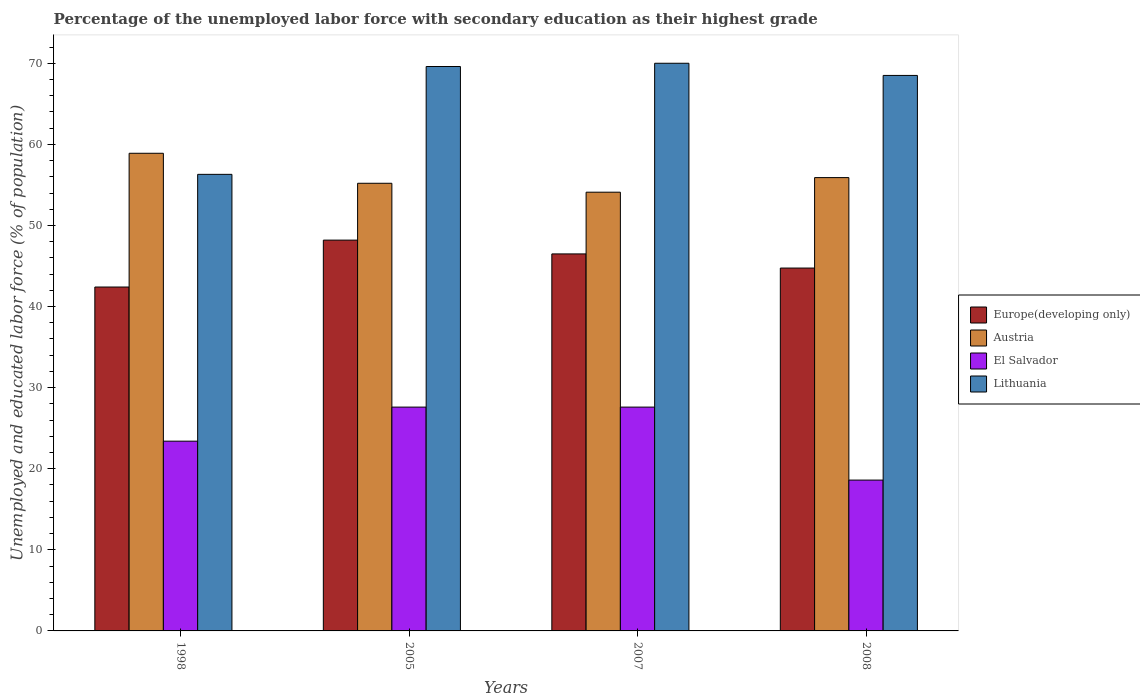How many different coloured bars are there?
Offer a terse response. 4. How many groups of bars are there?
Keep it short and to the point. 4. Are the number of bars on each tick of the X-axis equal?
Provide a short and direct response. Yes. How many bars are there on the 4th tick from the right?
Your response must be concise. 4. What is the label of the 2nd group of bars from the left?
Keep it short and to the point. 2005. What is the percentage of the unemployed labor force with secondary education in Lithuania in 2005?
Provide a short and direct response. 69.6. Across all years, what is the maximum percentage of the unemployed labor force with secondary education in Austria?
Keep it short and to the point. 58.9. Across all years, what is the minimum percentage of the unemployed labor force with secondary education in Lithuania?
Give a very brief answer. 56.3. In which year was the percentage of the unemployed labor force with secondary education in Europe(developing only) maximum?
Give a very brief answer. 2005. What is the total percentage of the unemployed labor force with secondary education in Austria in the graph?
Ensure brevity in your answer.  224.1. What is the difference between the percentage of the unemployed labor force with secondary education in El Salvador in 1998 and that in 2008?
Offer a terse response. 4.8. What is the difference between the percentage of the unemployed labor force with secondary education in Austria in 2008 and the percentage of the unemployed labor force with secondary education in Europe(developing only) in 2005?
Ensure brevity in your answer.  7.71. What is the average percentage of the unemployed labor force with secondary education in El Salvador per year?
Keep it short and to the point. 24.3. In the year 2007, what is the difference between the percentage of the unemployed labor force with secondary education in El Salvador and percentage of the unemployed labor force with secondary education in Austria?
Offer a very short reply. -26.5. In how many years, is the percentage of the unemployed labor force with secondary education in Austria greater than 70 %?
Provide a succinct answer. 0. What is the ratio of the percentage of the unemployed labor force with secondary education in El Salvador in 2005 to that in 2008?
Give a very brief answer. 1.48. Is the percentage of the unemployed labor force with secondary education in Lithuania in 1998 less than that in 2005?
Your response must be concise. Yes. What is the difference between the highest and the second highest percentage of the unemployed labor force with secondary education in Austria?
Your answer should be very brief. 3. What is the difference between the highest and the lowest percentage of the unemployed labor force with secondary education in Lithuania?
Keep it short and to the point. 13.7. Is it the case that in every year, the sum of the percentage of the unemployed labor force with secondary education in Austria and percentage of the unemployed labor force with secondary education in El Salvador is greater than the sum of percentage of the unemployed labor force with secondary education in Europe(developing only) and percentage of the unemployed labor force with secondary education in Lithuania?
Give a very brief answer. No. What does the 1st bar from the left in 2007 represents?
Ensure brevity in your answer.  Europe(developing only). What does the 1st bar from the right in 2005 represents?
Keep it short and to the point. Lithuania. What is the difference between two consecutive major ticks on the Y-axis?
Make the answer very short. 10. Are the values on the major ticks of Y-axis written in scientific E-notation?
Keep it short and to the point. No. How many legend labels are there?
Offer a very short reply. 4. How are the legend labels stacked?
Offer a terse response. Vertical. What is the title of the graph?
Your answer should be very brief. Percentage of the unemployed labor force with secondary education as their highest grade. Does "European Union" appear as one of the legend labels in the graph?
Give a very brief answer. No. What is the label or title of the Y-axis?
Offer a very short reply. Unemployed and educated labor force (% of population). What is the Unemployed and educated labor force (% of population) of Europe(developing only) in 1998?
Give a very brief answer. 42.41. What is the Unemployed and educated labor force (% of population) of Austria in 1998?
Your answer should be very brief. 58.9. What is the Unemployed and educated labor force (% of population) of El Salvador in 1998?
Provide a succinct answer. 23.4. What is the Unemployed and educated labor force (% of population) of Lithuania in 1998?
Offer a very short reply. 56.3. What is the Unemployed and educated labor force (% of population) of Europe(developing only) in 2005?
Provide a succinct answer. 48.19. What is the Unemployed and educated labor force (% of population) in Austria in 2005?
Provide a succinct answer. 55.2. What is the Unemployed and educated labor force (% of population) of El Salvador in 2005?
Give a very brief answer. 27.6. What is the Unemployed and educated labor force (% of population) in Lithuania in 2005?
Offer a terse response. 69.6. What is the Unemployed and educated labor force (% of population) in Europe(developing only) in 2007?
Keep it short and to the point. 46.49. What is the Unemployed and educated labor force (% of population) in Austria in 2007?
Provide a succinct answer. 54.1. What is the Unemployed and educated labor force (% of population) of El Salvador in 2007?
Ensure brevity in your answer.  27.6. What is the Unemployed and educated labor force (% of population) of Europe(developing only) in 2008?
Offer a terse response. 44.75. What is the Unemployed and educated labor force (% of population) in Austria in 2008?
Keep it short and to the point. 55.9. What is the Unemployed and educated labor force (% of population) of El Salvador in 2008?
Offer a very short reply. 18.6. What is the Unemployed and educated labor force (% of population) of Lithuania in 2008?
Give a very brief answer. 68.5. Across all years, what is the maximum Unemployed and educated labor force (% of population) in Europe(developing only)?
Keep it short and to the point. 48.19. Across all years, what is the maximum Unemployed and educated labor force (% of population) of Austria?
Ensure brevity in your answer.  58.9. Across all years, what is the maximum Unemployed and educated labor force (% of population) in El Salvador?
Offer a terse response. 27.6. Across all years, what is the minimum Unemployed and educated labor force (% of population) of Europe(developing only)?
Give a very brief answer. 42.41. Across all years, what is the minimum Unemployed and educated labor force (% of population) in Austria?
Your response must be concise. 54.1. Across all years, what is the minimum Unemployed and educated labor force (% of population) in El Salvador?
Your answer should be very brief. 18.6. Across all years, what is the minimum Unemployed and educated labor force (% of population) in Lithuania?
Ensure brevity in your answer.  56.3. What is the total Unemployed and educated labor force (% of population) in Europe(developing only) in the graph?
Make the answer very short. 181.83. What is the total Unemployed and educated labor force (% of population) in Austria in the graph?
Ensure brevity in your answer.  224.1. What is the total Unemployed and educated labor force (% of population) in El Salvador in the graph?
Your response must be concise. 97.2. What is the total Unemployed and educated labor force (% of population) in Lithuania in the graph?
Your answer should be compact. 264.4. What is the difference between the Unemployed and educated labor force (% of population) of Europe(developing only) in 1998 and that in 2005?
Offer a terse response. -5.78. What is the difference between the Unemployed and educated labor force (% of population) in Austria in 1998 and that in 2005?
Provide a short and direct response. 3.7. What is the difference between the Unemployed and educated labor force (% of population) of El Salvador in 1998 and that in 2005?
Provide a short and direct response. -4.2. What is the difference between the Unemployed and educated labor force (% of population) of Lithuania in 1998 and that in 2005?
Offer a terse response. -13.3. What is the difference between the Unemployed and educated labor force (% of population) of Europe(developing only) in 1998 and that in 2007?
Give a very brief answer. -4.08. What is the difference between the Unemployed and educated labor force (% of population) of Lithuania in 1998 and that in 2007?
Your response must be concise. -13.7. What is the difference between the Unemployed and educated labor force (% of population) in Europe(developing only) in 1998 and that in 2008?
Keep it short and to the point. -2.34. What is the difference between the Unemployed and educated labor force (% of population) of Austria in 1998 and that in 2008?
Give a very brief answer. 3. What is the difference between the Unemployed and educated labor force (% of population) in Lithuania in 1998 and that in 2008?
Make the answer very short. -12.2. What is the difference between the Unemployed and educated labor force (% of population) of Europe(developing only) in 2005 and that in 2007?
Your response must be concise. 1.7. What is the difference between the Unemployed and educated labor force (% of population) of Europe(developing only) in 2005 and that in 2008?
Provide a succinct answer. 3.44. What is the difference between the Unemployed and educated labor force (% of population) in El Salvador in 2005 and that in 2008?
Provide a short and direct response. 9. What is the difference between the Unemployed and educated labor force (% of population) in Europe(developing only) in 2007 and that in 2008?
Provide a succinct answer. 1.75. What is the difference between the Unemployed and educated labor force (% of population) of El Salvador in 2007 and that in 2008?
Offer a terse response. 9. What is the difference between the Unemployed and educated labor force (% of population) of Lithuania in 2007 and that in 2008?
Give a very brief answer. 1.5. What is the difference between the Unemployed and educated labor force (% of population) of Europe(developing only) in 1998 and the Unemployed and educated labor force (% of population) of Austria in 2005?
Your answer should be very brief. -12.79. What is the difference between the Unemployed and educated labor force (% of population) of Europe(developing only) in 1998 and the Unemployed and educated labor force (% of population) of El Salvador in 2005?
Provide a succinct answer. 14.81. What is the difference between the Unemployed and educated labor force (% of population) in Europe(developing only) in 1998 and the Unemployed and educated labor force (% of population) in Lithuania in 2005?
Offer a terse response. -27.19. What is the difference between the Unemployed and educated labor force (% of population) of Austria in 1998 and the Unemployed and educated labor force (% of population) of El Salvador in 2005?
Keep it short and to the point. 31.3. What is the difference between the Unemployed and educated labor force (% of population) of Austria in 1998 and the Unemployed and educated labor force (% of population) of Lithuania in 2005?
Your answer should be very brief. -10.7. What is the difference between the Unemployed and educated labor force (% of population) in El Salvador in 1998 and the Unemployed and educated labor force (% of population) in Lithuania in 2005?
Give a very brief answer. -46.2. What is the difference between the Unemployed and educated labor force (% of population) of Europe(developing only) in 1998 and the Unemployed and educated labor force (% of population) of Austria in 2007?
Keep it short and to the point. -11.69. What is the difference between the Unemployed and educated labor force (% of population) in Europe(developing only) in 1998 and the Unemployed and educated labor force (% of population) in El Salvador in 2007?
Ensure brevity in your answer.  14.81. What is the difference between the Unemployed and educated labor force (% of population) of Europe(developing only) in 1998 and the Unemployed and educated labor force (% of population) of Lithuania in 2007?
Provide a short and direct response. -27.59. What is the difference between the Unemployed and educated labor force (% of population) of Austria in 1998 and the Unemployed and educated labor force (% of population) of El Salvador in 2007?
Offer a very short reply. 31.3. What is the difference between the Unemployed and educated labor force (% of population) in El Salvador in 1998 and the Unemployed and educated labor force (% of population) in Lithuania in 2007?
Your answer should be compact. -46.6. What is the difference between the Unemployed and educated labor force (% of population) of Europe(developing only) in 1998 and the Unemployed and educated labor force (% of population) of Austria in 2008?
Your response must be concise. -13.49. What is the difference between the Unemployed and educated labor force (% of population) of Europe(developing only) in 1998 and the Unemployed and educated labor force (% of population) of El Salvador in 2008?
Your answer should be very brief. 23.81. What is the difference between the Unemployed and educated labor force (% of population) in Europe(developing only) in 1998 and the Unemployed and educated labor force (% of population) in Lithuania in 2008?
Your answer should be very brief. -26.09. What is the difference between the Unemployed and educated labor force (% of population) in Austria in 1998 and the Unemployed and educated labor force (% of population) in El Salvador in 2008?
Provide a succinct answer. 40.3. What is the difference between the Unemployed and educated labor force (% of population) of Austria in 1998 and the Unemployed and educated labor force (% of population) of Lithuania in 2008?
Offer a very short reply. -9.6. What is the difference between the Unemployed and educated labor force (% of population) in El Salvador in 1998 and the Unemployed and educated labor force (% of population) in Lithuania in 2008?
Make the answer very short. -45.1. What is the difference between the Unemployed and educated labor force (% of population) in Europe(developing only) in 2005 and the Unemployed and educated labor force (% of population) in Austria in 2007?
Your response must be concise. -5.91. What is the difference between the Unemployed and educated labor force (% of population) in Europe(developing only) in 2005 and the Unemployed and educated labor force (% of population) in El Salvador in 2007?
Provide a succinct answer. 20.59. What is the difference between the Unemployed and educated labor force (% of population) of Europe(developing only) in 2005 and the Unemployed and educated labor force (% of population) of Lithuania in 2007?
Provide a short and direct response. -21.81. What is the difference between the Unemployed and educated labor force (% of population) of Austria in 2005 and the Unemployed and educated labor force (% of population) of El Salvador in 2007?
Provide a succinct answer. 27.6. What is the difference between the Unemployed and educated labor force (% of population) of Austria in 2005 and the Unemployed and educated labor force (% of population) of Lithuania in 2007?
Give a very brief answer. -14.8. What is the difference between the Unemployed and educated labor force (% of population) of El Salvador in 2005 and the Unemployed and educated labor force (% of population) of Lithuania in 2007?
Keep it short and to the point. -42.4. What is the difference between the Unemployed and educated labor force (% of population) of Europe(developing only) in 2005 and the Unemployed and educated labor force (% of population) of Austria in 2008?
Keep it short and to the point. -7.71. What is the difference between the Unemployed and educated labor force (% of population) of Europe(developing only) in 2005 and the Unemployed and educated labor force (% of population) of El Salvador in 2008?
Ensure brevity in your answer.  29.59. What is the difference between the Unemployed and educated labor force (% of population) in Europe(developing only) in 2005 and the Unemployed and educated labor force (% of population) in Lithuania in 2008?
Your answer should be compact. -20.31. What is the difference between the Unemployed and educated labor force (% of population) in Austria in 2005 and the Unemployed and educated labor force (% of population) in El Salvador in 2008?
Your response must be concise. 36.6. What is the difference between the Unemployed and educated labor force (% of population) in El Salvador in 2005 and the Unemployed and educated labor force (% of population) in Lithuania in 2008?
Make the answer very short. -40.9. What is the difference between the Unemployed and educated labor force (% of population) of Europe(developing only) in 2007 and the Unemployed and educated labor force (% of population) of Austria in 2008?
Offer a very short reply. -9.41. What is the difference between the Unemployed and educated labor force (% of population) in Europe(developing only) in 2007 and the Unemployed and educated labor force (% of population) in El Salvador in 2008?
Your answer should be compact. 27.89. What is the difference between the Unemployed and educated labor force (% of population) of Europe(developing only) in 2007 and the Unemployed and educated labor force (% of population) of Lithuania in 2008?
Provide a succinct answer. -22.01. What is the difference between the Unemployed and educated labor force (% of population) of Austria in 2007 and the Unemployed and educated labor force (% of population) of El Salvador in 2008?
Provide a succinct answer. 35.5. What is the difference between the Unemployed and educated labor force (% of population) in Austria in 2007 and the Unemployed and educated labor force (% of population) in Lithuania in 2008?
Your answer should be very brief. -14.4. What is the difference between the Unemployed and educated labor force (% of population) of El Salvador in 2007 and the Unemployed and educated labor force (% of population) of Lithuania in 2008?
Offer a very short reply. -40.9. What is the average Unemployed and educated labor force (% of population) of Europe(developing only) per year?
Offer a very short reply. 45.46. What is the average Unemployed and educated labor force (% of population) of Austria per year?
Provide a succinct answer. 56.02. What is the average Unemployed and educated labor force (% of population) in El Salvador per year?
Your answer should be very brief. 24.3. What is the average Unemployed and educated labor force (% of population) in Lithuania per year?
Your response must be concise. 66.1. In the year 1998, what is the difference between the Unemployed and educated labor force (% of population) in Europe(developing only) and Unemployed and educated labor force (% of population) in Austria?
Your response must be concise. -16.49. In the year 1998, what is the difference between the Unemployed and educated labor force (% of population) of Europe(developing only) and Unemployed and educated labor force (% of population) of El Salvador?
Offer a very short reply. 19.01. In the year 1998, what is the difference between the Unemployed and educated labor force (% of population) in Europe(developing only) and Unemployed and educated labor force (% of population) in Lithuania?
Provide a short and direct response. -13.89. In the year 1998, what is the difference between the Unemployed and educated labor force (% of population) in Austria and Unemployed and educated labor force (% of population) in El Salvador?
Provide a succinct answer. 35.5. In the year 1998, what is the difference between the Unemployed and educated labor force (% of population) of Austria and Unemployed and educated labor force (% of population) of Lithuania?
Keep it short and to the point. 2.6. In the year 1998, what is the difference between the Unemployed and educated labor force (% of population) of El Salvador and Unemployed and educated labor force (% of population) of Lithuania?
Your answer should be very brief. -32.9. In the year 2005, what is the difference between the Unemployed and educated labor force (% of population) in Europe(developing only) and Unemployed and educated labor force (% of population) in Austria?
Provide a succinct answer. -7.01. In the year 2005, what is the difference between the Unemployed and educated labor force (% of population) of Europe(developing only) and Unemployed and educated labor force (% of population) of El Salvador?
Offer a very short reply. 20.59. In the year 2005, what is the difference between the Unemployed and educated labor force (% of population) of Europe(developing only) and Unemployed and educated labor force (% of population) of Lithuania?
Offer a very short reply. -21.41. In the year 2005, what is the difference between the Unemployed and educated labor force (% of population) of Austria and Unemployed and educated labor force (% of population) of El Salvador?
Your answer should be very brief. 27.6. In the year 2005, what is the difference between the Unemployed and educated labor force (% of population) of Austria and Unemployed and educated labor force (% of population) of Lithuania?
Offer a terse response. -14.4. In the year 2005, what is the difference between the Unemployed and educated labor force (% of population) in El Salvador and Unemployed and educated labor force (% of population) in Lithuania?
Make the answer very short. -42. In the year 2007, what is the difference between the Unemployed and educated labor force (% of population) in Europe(developing only) and Unemployed and educated labor force (% of population) in Austria?
Your answer should be very brief. -7.61. In the year 2007, what is the difference between the Unemployed and educated labor force (% of population) in Europe(developing only) and Unemployed and educated labor force (% of population) in El Salvador?
Your answer should be compact. 18.89. In the year 2007, what is the difference between the Unemployed and educated labor force (% of population) of Europe(developing only) and Unemployed and educated labor force (% of population) of Lithuania?
Offer a very short reply. -23.51. In the year 2007, what is the difference between the Unemployed and educated labor force (% of population) in Austria and Unemployed and educated labor force (% of population) in El Salvador?
Your response must be concise. 26.5. In the year 2007, what is the difference between the Unemployed and educated labor force (% of population) in Austria and Unemployed and educated labor force (% of population) in Lithuania?
Keep it short and to the point. -15.9. In the year 2007, what is the difference between the Unemployed and educated labor force (% of population) in El Salvador and Unemployed and educated labor force (% of population) in Lithuania?
Your answer should be compact. -42.4. In the year 2008, what is the difference between the Unemployed and educated labor force (% of population) of Europe(developing only) and Unemployed and educated labor force (% of population) of Austria?
Ensure brevity in your answer.  -11.15. In the year 2008, what is the difference between the Unemployed and educated labor force (% of population) in Europe(developing only) and Unemployed and educated labor force (% of population) in El Salvador?
Your answer should be compact. 26.15. In the year 2008, what is the difference between the Unemployed and educated labor force (% of population) of Europe(developing only) and Unemployed and educated labor force (% of population) of Lithuania?
Give a very brief answer. -23.75. In the year 2008, what is the difference between the Unemployed and educated labor force (% of population) of Austria and Unemployed and educated labor force (% of population) of El Salvador?
Offer a very short reply. 37.3. In the year 2008, what is the difference between the Unemployed and educated labor force (% of population) of El Salvador and Unemployed and educated labor force (% of population) of Lithuania?
Keep it short and to the point. -49.9. What is the ratio of the Unemployed and educated labor force (% of population) in Europe(developing only) in 1998 to that in 2005?
Give a very brief answer. 0.88. What is the ratio of the Unemployed and educated labor force (% of population) of Austria in 1998 to that in 2005?
Offer a terse response. 1.07. What is the ratio of the Unemployed and educated labor force (% of population) in El Salvador in 1998 to that in 2005?
Make the answer very short. 0.85. What is the ratio of the Unemployed and educated labor force (% of population) of Lithuania in 1998 to that in 2005?
Offer a very short reply. 0.81. What is the ratio of the Unemployed and educated labor force (% of population) of Europe(developing only) in 1998 to that in 2007?
Make the answer very short. 0.91. What is the ratio of the Unemployed and educated labor force (% of population) of Austria in 1998 to that in 2007?
Your response must be concise. 1.09. What is the ratio of the Unemployed and educated labor force (% of population) of El Salvador in 1998 to that in 2007?
Ensure brevity in your answer.  0.85. What is the ratio of the Unemployed and educated labor force (% of population) in Lithuania in 1998 to that in 2007?
Keep it short and to the point. 0.8. What is the ratio of the Unemployed and educated labor force (% of population) in Europe(developing only) in 1998 to that in 2008?
Offer a very short reply. 0.95. What is the ratio of the Unemployed and educated labor force (% of population) in Austria in 1998 to that in 2008?
Provide a short and direct response. 1.05. What is the ratio of the Unemployed and educated labor force (% of population) of El Salvador in 1998 to that in 2008?
Ensure brevity in your answer.  1.26. What is the ratio of the Unemployed and educated labor force (% of population) of Lithuania in 1998 to that in 2008?
Your answer should be very brief. 0.82. What is the ratio of the Unemployed and educated labor force (% of population) of Europe(developing only) in 2005 to that in 2007?
Provide a succinct answer. 1.04. What is the ratio of the Unemployed and educated labor force (% of population) of Austria in 2005 to that in 2007?
Make the answer very short. 1.02. What is the ratio of the Unemployed and educated labor force (% of population) in El Salvador in 2005 to that in 2007?
Your answer should be very brief. 1. What is the ratio of the Unemployed and educated labor force (% of population) in Lithuania in 2005 to that in 2007?
Offer a terse response. 0.99. What is the ratio of the Unemployed and educated labor force (% of population) in Europe(developing only) in 2005 to that in 2008?
Ensure brevity in your answer.  1.08. What is the ratio of the Unemployed and educated labor force (% of population) in Austria in 2005 to that in 2008?
Ensure brevity in your answer.  0.99. What is the ratio of the Unemployed and educated labor force (% of population) of El Salvador in 2005 to that in 2008?
Keep it short and to the point. 1.48. What is the ratio of the Unemployed and educated labor force (% of population) of Lithuania in 2005 to that in 2008?
Ensure brevity in your answer.  1.02. What is the ratio of the Unemployed and educated labor force (% of population) of Europe(developing only) in 2007 to that in 2008?
Keep it short and to the point. 1.04. What is the ratio of the Unemployed and educated labor force (% of population) in Austria in 2007 to that in 2008?
Provide a short and direct response. 0.97. What is the ratio of the Unemployed and educated labor force (% of population) of El Salvador in 2007 to that in 2008?
Offer a terse response. 1.48. What is the ratio of the Unemployed and educated labor force (% of population) in Lithuania in 2007 to that in 2008?
Ensure brevity in your answer.  1.02. What is the difference between the highest and the second highest Unemployed and educated labor force (% of population) of Europe(developing only)?
Offer a terse response. 1.7. What is the difference between the highest and the second highest Unemployed and educated labor force (% of population) in Austria?
Ensure brevity in your answer.  3. What is the difference between the highest and the second highest Unemployed and educated labor force (% of population) of El Salvador?
Make the answer very short. 0. What is the difference between the highest and the second highest Unemployed and educated labor force (% of population) in Lithuania?
Provide a short and direct response. 0.4. What is the difference between the highest and the lowest Unemployed and educated labor force (% of population) in Europe(developing only)?
Make the answer very short. 5.78. What is the difference between the highest and the lowest Unemployed and educated labor force (% of population) of El Salvador?
Give a very brief answer. 9. What is the difference between the highest and the lowest Unemployed and educated labor force (% of population) of Lithuania?
Offer a very short reply. 13.7. 